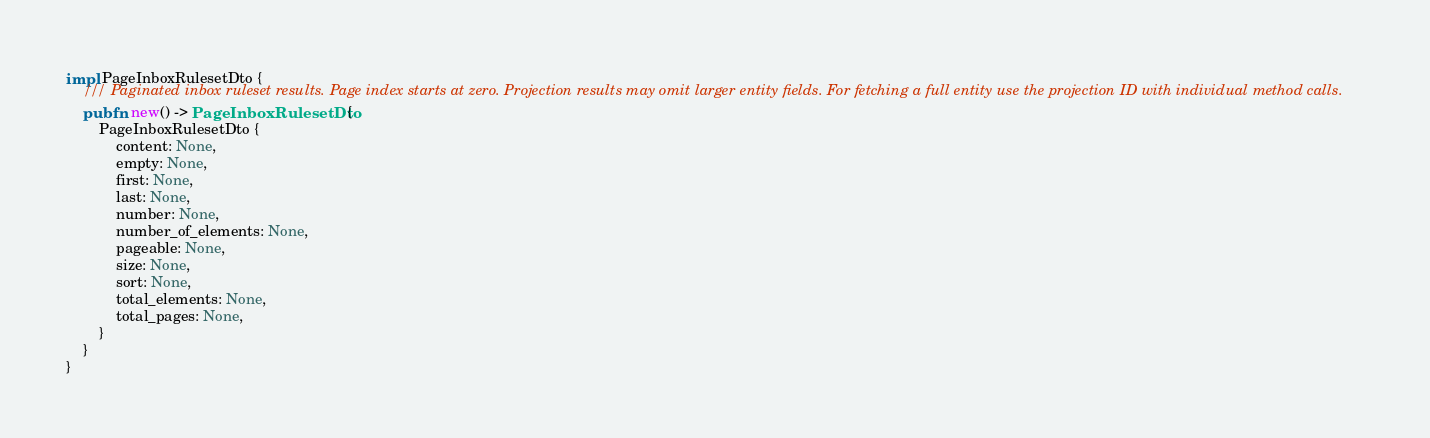Convert code to text. <code><loc_0><loc_0><loc_500><loc_500><_Rust_>impl PageInboxRulesetDto {
    /// Paginated inbox ruleset results. Page index starts at zero. Projection results may omit larger entity fields. For fetching a full entity use the projection ID with individual method calls.
    pub fn new() -> PageInboxRulesetDto {
        PageInboxRulesetDto {
            content: None,
            empty: None,
            first: None,
            last: None,
            number: None,
            number_of_elements: None,
            pageable: None,
            size: None,
            sort: None,
            total_elements: None,
            total_pages: None,
        }
    }
}


</code> 